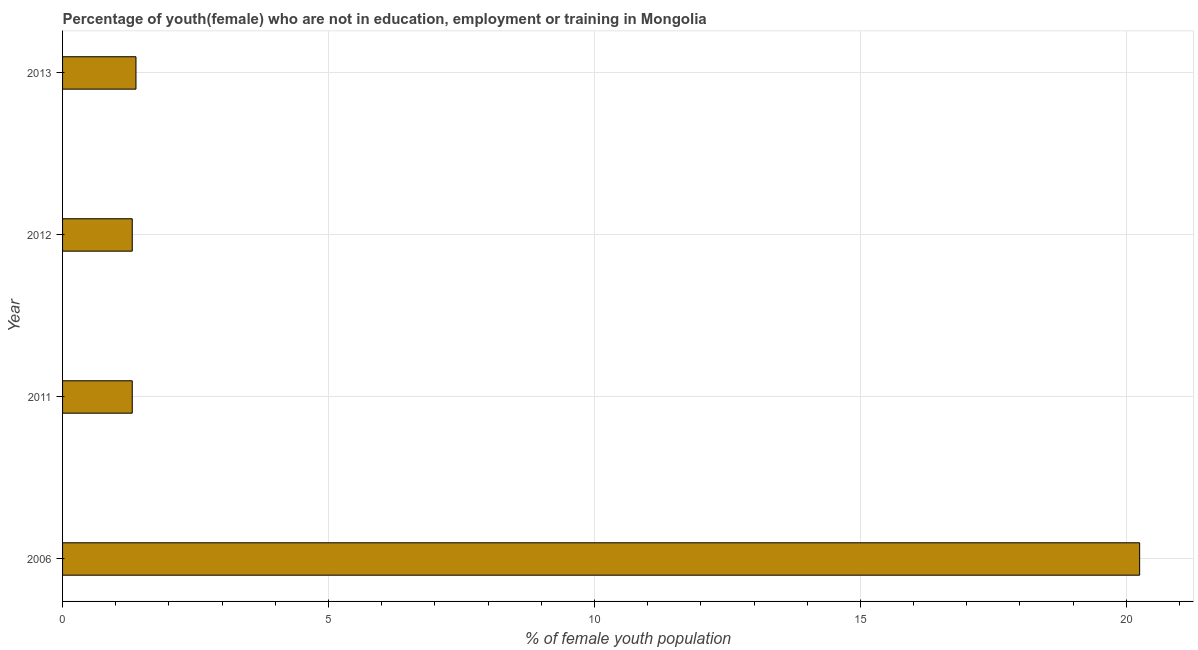Does the graph contain any zero values?
Ensure brevity in your answer.  No. Does the graph contain grids?
Your response must be concise. Yes. What is the title of the graph?
Provide a succinct answer. Percentage of youth(female) who are not in education, employment or training in Mongolia. What is the label or title of the X-axis?
Keep it short and to the point. % of female youth population. What is the label or title of the Y-axis?
Keep it short and to the point. Year. What is the unemployed female youth population in 2012?
Your answer should be compact. 1.31. Across all years, what is the maximum unemployed female youth population?
Make the answer very short. 20.25. Across all years, what is the minimum unemployed female youth population?
Your answer should be compact. 1.31. In which year was the unemployed female youth population maximum?
Provide a succinct answer. 2006. In which year was the unemployed female youth population minimum?
Make the answer very short. 2011. What is the sum of the unemployed female youth population?
Provide a short and direct response. 24.25. What is the difference between the unemployed female youth population in 2011 and 2013?
Offer a very short reply. -0.07. What is the average unemployed female youth population per year?
Your answer should be compact. 6.06. What is the median unemployed female youth population?
Keep it short and to the point. 1.34. In how many years, is the unemployed female youth population greater than 18 %?
Make the answer very short. 1. What is the ratio of the unemployed female youth population in 2011 to that in 2013?
Give a very brief answer. 0.95. Is the unemployed female youth population in 2011 less than that in 2013?
Ensure brevity in your answer.  Yes. Is the difference between the unemployed female youth population in 2011 and 2012 greater than the difference between any two years?
Your response must be concise. No. What is the difference between the highest and the second highest unemployed female youth population?
Ensure brevity in your answer.  18.87. Is the sum of the unemployed female youth population in 2011 and 2013 greater than the maximum unemployed female youth population across all years?
Your response must be concise. No. What is the difference between the highest and the lowest unemployed female youth population?
Provide a succinct answer. 18.94. In how many years, is the unemployed female youth population greater than the average unemployed female youth population taken over all years?
Provide a short and direct response. 1. Are all the bars in the graph horizontal?
Make the answer very short. Yes. How many years are there in the graph?
Your answer should be compact. 4. What is the difference between two consecutive major ticks on the X-axis?
Your response must be concise. 5. What is the % of female youth population of 2006?
Your response must be concise. 20.25. What is the % of female youth population in 2011?
Your answer should be compact. 1.31. What is the % of female youth population of 2012?
Your answer should be very brief. 1.31. What is the % of female youth population in 2013?
Ensure brevity in your answer.  1.38. What is the difference between the % of female youth population in 2006 and 2011?
Give a very brief answer. 18.94. What is the difference between the % of female youth population in 2006 and 2012?
Your answer should be compact. 18.94. What is the difference between the % of female youth population in 2006 and 2013?
Make the answer very short. 18.87. What is the difference between the % of female youth population in 2011 and 2013?
Keep it short and to the point. -0.07. What is the difference between the % of female youth population in 2012 and 2013?
Keep it short and to the point. -0.07. What is the ratio of the % of female youth population in 2006 to that in 2011?
Keep it short and to the point. 15.46. What is the ratio of the % of female youth population in 2006 to that in 2012?
Ensure brevity in your answer.  15.46. What is the ratio of the % of female youth population in 2006 to that in 2013?
Offer a terse response. 14.67. What is the ratio of the % of female youth population in 2011 to that in 2013?
Provide a succinct answer. 0.95. What is the ratio of the % of female youth population in 2012 to that in 2013?
Keep it short and to the point. 0.95. 